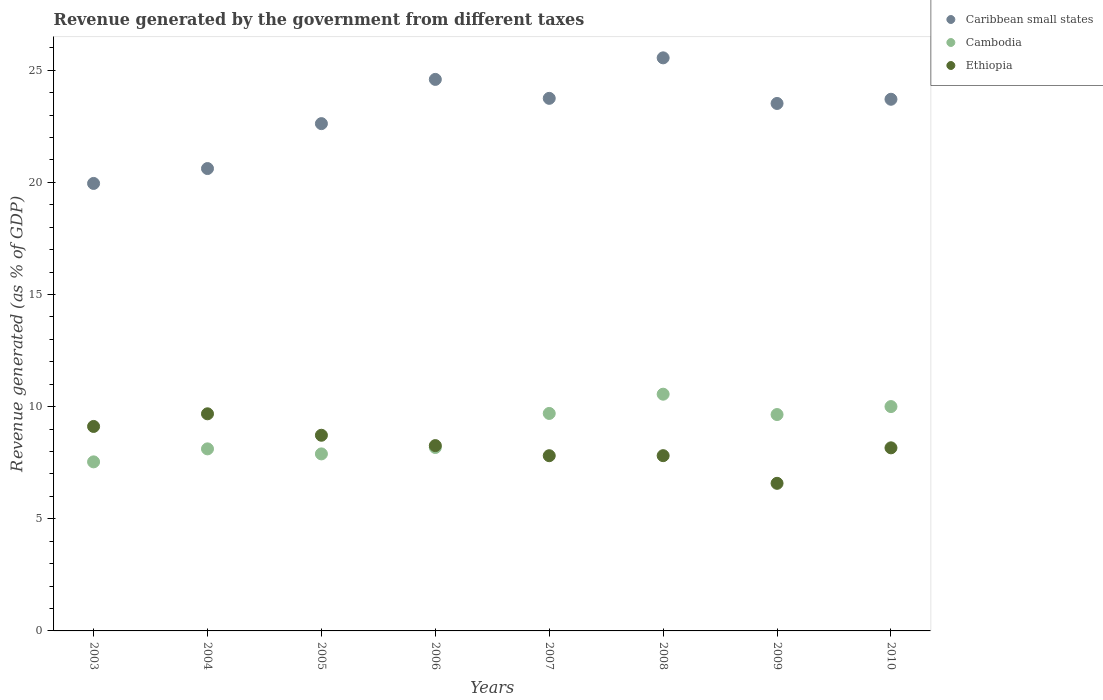How many different coloured dotlines are there?
Ensure brevity in your answer.  3. What is the revenue generated by the government in Ethiopia in 2003?
Make the answer very short. 9.12. Across all years, what is the maximum revenue generated by the government in Cambodia?
Make the answer very short. 10.56. Across all years, what is the minimum revenue generated by the government in Caribbean small states?
Provide a succinct answer. 19.95. In which year was the revenue generated by the government in Ethiopia minimum?
Make the answer very short. 2009. What is the total revenue generated by the government in Ethiopia in the graph?
Your answer should be compact. 66.16. What is the difference between the revenue generated by the government in Ethiopia in 2004 and that in 2006?
Your response must be concise. 1.42. What is the difference between the revenue generated by the government in Ethiopia in 2003 and the revenue generated by the government in Caribbean small states in 2009?
Make the answer very short. -14.4. What is the average revenue generated by the government in Cambodia per year?
Offer a terse response. 8.95. In the year 2008, what is the difference between the revenue generated by the government in Caribbean small states and revenue generated by the government in Ethiopia?
Give a very brief answer. 17.74. In how many years, is the revenue generated by the government in Cambodia greater than 13 %?
Your answer should be very brief. 0. What is the ratio of the revenue generated by the government in Cambodia in 2003 to that in 2008?
Offer a terse response. 0.71. What is the difference between the highest and the second highest revenue generated by the government in Ethiopia?
Give a very brief answer. 0.56. What is the difference between the highest and the lowest revenue generated by the government in Cambodia?
Keep it short and to the point. 3.02. In how many years, is the revenue generated by the government in Caribbean small states greater than the average revenue generated by the government in Caribbean small states taken over all years?
Your response must be concise. 5. Is the revenue generated by the government in Cambodia strictly greater than the revenue generated by the government in Ethiopia over the years?
Make the answer very short. No. What is the difference between two consecutive major ticks on the Y-axis?
Make the answer very short. 5. Does the graph contain any zero values?
Keep it short and to the point. No. Where does the legend appear in the graph?
Give a very brief answer. Top right. How many legend labels are there?
Your answer should be compact. 3. What is the title of the graph?
Keep it short and to the point. Revenue generated by the government from different taxes. What is the label or title of the Y-axis?
Your answer should be compact. Revenue generated (as % of GDP). What is the Revenue generated (as % of GDP) of Caribbean small states in 2003?
Ensure brevity in your answer.  19.95. What is the Revenue generated (as % of GDP) of Cambodia in 2003?
Your response must be concise. 7.54. What is the Revenue generated (as % of GDP) in Ethiopia in 2003?
Your answer should be compact. 9.12. What is the Revenue generated (as % of GDP) in Caribbean small states in 2004?
Your response must be concise. 20.62. What is the Revenue generated (as % of GDP) of Cambodia in 2004?
Make the answer very short. 8.12. What is the Revenue generated (as % of GDP) in Ethiopia in 2004?
Keep it short and to the point. 9.68. What is the Revenue generated (as % of GDP) in Caribbean small states in 2005?
Provide a short and direct response. 22.62. What is the Revenue generated (as % of GDP) in Cambodia in 2005?
Keep it short and to the point. 7.89. What is the Revenue generated (as % of GDP) of Ethiopia in 2005?
Your response must be concise. 8.72. What is the Revenue generated (as % of GDP) of Caribbean small states in 2006?
Your answer should be compact. 24.59. What is the Revenue generated (as % of GDP) of Cambodia in 2006?
Ensure brevity in your answer.  8.18. What is the Revenue generated (as % of GDP) of Ethiopia in 2006?
Offer a very short reply. 8.26. What is the Revenue generated (as % of GDP) in Caribbean small states in 2007?
Provide a succinct answer. 23.75. What is the Revenue generated (as % of GDP) in Cambodia in 2007?
Offer a terse response. 9.7. What is the Revenue generated (as % of GDP) of Ethiopia in 2007?
Provide a succinct answer. 7.81. What is the Revenue generated (as % of GDP) of Caribbean small states in 2008?
Provide a succinct answer. 25.55. What is the Revenue generated (as % of GDP) in Cambodia in 2008?
Keep it short and to the point. 10.56. What is the Revenue generated (as % of GDP) of Ethiopia in 2008?
Provide a short and direct response. 7.81. What is the Revenue generated (as % of GDP) in Caribbean small states in 2009?
Your response must be concise. 23.52. What is the Revenue generated (as % of GDP) of Cambodia in 2009?
Your response must be concise. 9.65. What is the Revenue generated (as % of GDP) in Ethiopia in 2009?
Ensure brevity in your answer.  6.58. What is the Revenue generated (as % of GDP) in Caribbean small states in 2010?
Give a very brief answer. 23.71. What is the Revenue generated (as % of GDP) of Cambodia in 2010?
Provide a succinct answer. 10. What is the Revenue generated (as % of GDP) of Ethiopia in 2010?
Make the answer very short. 8.16. Across all years, what is the maximum Revenue generated (as % of GDP) in Caribbean small states?
Provide a short and direct response. 25.55. Across all years, what is the maximum Revenue generated (as % of GDP) of Cambodia?
Offer a very short reply. 10.56. Across all years, what is the maximum Revenue generated (as % of GDP) of Ethiopia?
Your answer should be compact. 9.68. Across all years, what is the minimum Revenue generated (as % of GDP) in Caribbean small states?
Your answer should be very brief. 19.95. Across all years, what is the minimum Revenue generated (as % of GDP) in Cambodia?
Your answer should be very brief. 7.54. Across all years, what is the minimum Revenue generated (as % of GDP) in Ethiopia?
Provide a succinct answer. 6.58. What is the total Revenue generated (as % of GDP) in Caribbean small states in the graph?
Your answer should be very brief. 184.3. What is the total Revenue generated (as % of GDP) in Cambodia in the graph?
Offer a terse response. 71.63. What is the total Revenue generated (as % of GDP) in Ethiopia in the graph?
Your answer should be compact. 66.16. What is the difference between the Revenue generated (as % of GDP) of Caribbean small states in 2003 and that in 2004?
Make the answer very short. -0.66. What is the difference between the Revenue generated (as % of GDP) of Cambodia in 2003 and that in 2004?
Ensure brevity in your answer.  -0.58. What is the difference between the Revenue generated (as % of GDP) of Ethiopia in 2003 and that in 2004?
Your answer should be compact. -0.56. What is the difference between the Revenue generated (as % of GDP) in Caribbean small states in 2003 and that in 2005?
Make the answer very short. -2.67. What is the difference between the Revenue generated (as % of GDP) of Cambodia in 2003 and that in 2005?
Make the answer very short. -0.36. What is the difference between the Revenue generated (as % of GDP) of Ethiopia in 2003 and that in 2005?
Keep it short and to the point. 0.39. What is the difference between the Revenue generated (as % of GDP) in Caribbean small states in 2003 and that in 2006?
Ensure brevity in your answer.  -4.64. What is the difference between the Revenue generated (as % of GDP) in Cambodia in 2003 and that in 2006?
Ensure brevity in your answer.  -0.64. What is the difference between the Revenue generated (as % of GDP) in Ethiopia in 2003 and that in 2006?
Your answer should be compact. 0.85. What is the difference between the Revenue generated (as % of GDP) of Caribbean small states in 2003 and that in 2007?
Make the answer very short. -3.79. What is the difference between the Revenue generated (as % of GDP) of Cambodia in 2003 and that in 2007?
Provide a short and direct response. -2.16. What is the difference between the Revenue generated (as % of GDP) in Ethiopia in 2003 and that in 2007?
Your answer should be very brief. 1.3. What is the difference between the Revenue generated (as % of GDP) in Caribbean small states in 2003 and that in 2008?
Provide a succinct answer. -5.6. What is the difference between the Revenue generated (as % of GDP) in Cambodia in 2003 and that in 2008?
Your answer should be compact. -3.02. What is the difference between the Revenue generated (as % of GDP) in Ethiopia in 2003 and that in 2008?
Provide a succinct answer. 1.3. What is the difference between the Revenue generated (as % of GDP) of Caribbean small states in 2003 and that in 2009?
Your answer should be very brief. -3.57. What is the difference between the Revenue generated (as % of GDP) in Cambodia in 2003 and that in 2009?
Ensure brevity in your answer.  -2.11. What is the difference between the Revenue generated (as % of GDP) in Ethiopia in 2003 and that in 2009?
Offer a terse response. 2.54. What is the difference between the Revenue generated (as % of GDP) in Caribbean small states in 2003 and that in 2010?
Provide a succinct answer. -3.75. What is the difference between the Revenue generated (as % of GDP) in Cambodia in 2003 and that in 2010?
Ensure brevity in your answer.  -2.47. What is the difference between the Revenue generated (as % of GDP) of Ethiopia in 2003 and that in 2010?
Your response must be concise. 0.95. What is the difference between the Revenue generated (as % of GDP) in Caribbean small states in 2004 and that in 2005?
Provide a short and direct response. -2. What is the difference between the Revenue generated (as % of GDP) in Cambodia in 2004 and that in 2005?
Ensure brevity in your answer.  0.22. What is the difference between the Revenue generated (as % of GDP) of Ethiopia in 2004 and that in 2005?
Your answer should be compact. 0.96. What is the difference between the Revenue generated (as % of GDP) of Caribbean small states in 2004 and that in 2006?
Provide a short and direct response. -3.98. What is the difference between the Revenue generated (as % of GDP) in Cambodia in 2004 and that in 2006?
Your answer should be very brief. -0.06. What is the difference between the Revenue generated (as % of GDP) in Ethiopia in 2004 and that in 2006?
Offer a very short reply. 1.42. What is the difference between the Revenue generated (as % of GDP) in Caribbean small states in 2004 and that in 2007?
Offer a very short reply. -3.13. What is the difference between the Revenue generated (as % of GDP) in Cambodia in 2004 and that in 2007?
Provide a succinct answer. -1.58. What is the difference between the Revenue generated (as % of GDP) in Ethiopia in 2004 and that in 2007?
Provide a succinct answer. 1.87. What is the difference between the Revenue generated (as % of GDP) in Caribbean small states in 2004 and that in 2008?
Provide a succinct answer. -4.94. What is the difference between the Revenue generated (as % of GDP) of Cambodia in 2004 and that in 2008?
Give a very brief answer. -2.44. What is the difference between the Revenue generated (as % of GDP) of Ethiopia in 2004 and that in 2008?
Keep it short and to the point. 1.87. What is the difference between the Revenue generated (as % of GDP) of Caribbean small states in 2004 and that in 2009?
Ensure brevity in your answer.  -2.9. What is the difference between the Revenue generated (as % of GDP) in Cambodia in 2004 and that in 2009?
Provide a short and direct response. -1.53. What is the difference between the Revenue generated (as % of GDP) of Ethiopia in 2004 and that in 2009?
Your answer should be very brief. 3.1. What is the difference between the Revenue generated (as % of GDP) in Caribbean small states in 2004 and that in 2010?
Your answer should be very brief. -3.09. What is the difference between the Revenue generated (as % of GDP) in Cambodia in 2004 and that in 2010?
Offer a terse response. -1.89. What is the difference between the Revenue generated (as % of GDP) in Ethiopia in 2004 and that in 2010?
Keep it short and to the point. 1.52. What is the difference between the Revenue generated (as % of GDP) of Caribbean small states in 2005 and that in 2006?
Keep it short and to the point. -1.97. What is the difference between the Revenue generated (as % of GDP) of Cambodia in 2005 and that in 2006?
Your answer should be very brief. -0.29. What is the difference between the Revenue generated (as % of GDP) in Ethiopia in 2005 and that in 2006?
Your response must be concise. 0.46. What is the difference between the Revenue generated (as % of GDP) of Caribbean small states in 2005 and that in 2007?
Keep it short and to the point. -1.13. What is the difference between the Revenue generated (as % of GDP) of Cambodia in 2005 and that in 2007?
Your response must be concise. -1.8. What is the difference between the Revenue generated (as % of GDP) of Ethiopia in 2005 and that in 2007?
Offer a very short reply. 0.91. What is the difference between the Revenue generated (as % of GDP) in Caribbean small states in 2005 and that in 2008?
Provide a short and direct response. -2.93. What is the difference between the Revenue generated (as % of GDP) in Cambodia in 2005 and that in 2008?
Offer a very short reply. -2.66. What is the difference between the Revenue generated (as % of GDP) of Ethiopia in 2005 and that in 2008?
Provide a short and direct response. 0.91. What is the difference between the Revenue generated (as % of GDP) in Caribbean small states in 2005 and that in 2009?
Provide a short and direct response. -0.9. What is the difference between the Revenue generated (as % of GDP) in Cambodia in 2005 and that in 2009?
Your answer should be compact. -1.75. What is the difference between the Revenue generated (as % of GDP) of Ethiopia in 2005 and that in 2009?
Ensure brevity in your answer.  2.14. What is the difference between the Revenue generated (as % of GDP) of Caribbean small states in 2005 and that in 2010?
Keep it short and to the point. -1.09. What is the difference between the Revenue generated (as % of GDP) of Cambodia in 2005 and that in 2010?
Provide a succinct answer. -2.11. What is the difference between the Revenue generated (as % of GDP) of Ethiopia in 2005 and that in 2010?
Your response must be concise. 0.56. What is the difference between the Revenue generated (as % of GDP) in Caribbean small states in 2006 and that in 2007?
Give a very brief answer. 0.84. What is the difference between the Revenue generated (as % of GDP) in Cambodia in 2006 and that in 2007?
Ensure brevity in your answer.  -1.52. What is the difference between the Revenue generated (as % of GDP) of Ethiopia in 2006 and that in 2007?
Ensure brevity in your answer.  0.45. What is the difference between the Revenue generated (as % of GDP) of Caribbean small states in 2006 and that in 2008?
Keep it short and to the point. -0.96. What is the difference between the Revenue generated (as % of GDP) in Cambodia in 2006 and that in 2008?
Your answer should be compact. -2.38. What is the difference between the Revenue generated (as % of GDP) in Ethiopia in 2006 and that in 2008?
Your response must be concise. 0.45. What is the difference between the Revenue generated (as % of GDP) in Caribbean small states in 2006 and that in 2009?
Offer a very short reply. 1.07. What is the difference between the Revenue generated (as % of GDP) in Cambodia in 2006 and that in 2009?
Give a very brief answer. -1.47. What is the difference between the Revenue generated (as % of GDP) in Ethiopia in 2006 and that in 2009?
Provide a succinct answer. 1.68. What is the difference between the Revenue generated (as % of GDP) of Caribbean small states in 2006 and that in 2010?
Provide a short and direct response. 0.89. What is the difference between the Revenue generated (as % of GDP) in Cambodia in 2006 and that in 2010?
Your response must be concise. -1.82. What is the difference between the Revenue generated (as % of GDP) in Ethiopia in 2006 and that in 2010?
Offer a terse response. 0.1. What is the difference between the Revenue generated (as % of GDP) of Caribbean small states in 2007 and that in 2008?
Your response must be concise. -1.81. What is the difference between the Revenue generated (as % of GDP) in Cambodia in 2007 and that in 2008?
Offer a very short reply. -0.86. What is the difference between the Revenue generated (as % of GDP) in Ethiopia in 2007 and that in 2008?
Give a very brief answer. -0. What is the difference between the Revenue generated (as % of GDP) in Caribbean small states in 2007 and that in 2009?
Offer a terse response. 0.23. What is the difference between the Revenue generated (as % of GDP) in Cambodia in 2007 and that in 2009?
Your response must be concise. 0.05. What is the difference between the Revenue generated (as % of GDP) of Ethiopia in 2007 and that in 2009?
Provide a succinct answer. 1.23. What is the difference between the Revenue generated (as % of GDP) of Caribbean small states in 2007 and that in 2010?
Keep it short and to the point. 0.04. What is the difference between the Revenue generated (as % of GDP) in Cambodia in 2007 and that in 2010?
Offer a terse response. -0.31. What is the difference between the Revenue generated (as % of GDP) in Ethiopia in 2007 and that in 2010?
Provide a succinct answer. -0.35. What is the difference between the Revenue generated (as % of GDP) in Caribbean small states in 2008 and that in 2009?
Provide a short and direct response. 2.03. What is the difference between the Revenue generated (as % of GDP) in Cambodia in 2008 and that in 2009?
Make the answer very short. 0.91. What is the difference between the Revenue generated (as % of GDP) in Ethiopia in 2008 and that in 2009?
Provide a short and direct response. 1.23. What is the difference between the Revenue generated (as % of GDP) in Caribbean small states in 2008 and that in 2010?
Provide a short and direct response. 1.85. What is the difference between the Revenue generated (as % of GDP) in Cambodia in 2008 and that in 2010?
Give a very brief answer. 0.55. What is the difference between the Revenue generated (as % of GDP) in Ethiopia in 2008 and that in 2010?
Provide a succinct answer. -0.35. What is the difference between the Revenue generated (as % of GDP) in Caribbean small states in 2009 and that in 2010?
Provide a succinct answer. -0.19. What is the difference between the Revenue generated (as % of GDP) in Cambodia in 2009 and that in 2010?
Offer a very short reply. -0.36. What is the difference between the Revenue generated (as % of GDP) of Ethiopia in 2009 and that in 2010?
Ensure brevity in your answer.  -1.58. What is the difference between the Revenue generated (as % of GDP) of Caribbean small states in 2003 and the Revenue generated (as % of GDP) of Cambodia in 2004?
Your answer should be compact. 11.84. What is the difference between the Revenue generated (as % of GDP) in Caribbean small states in 2003 and the Revenue generated (as % of GDP) in Ethiopia in 2004?
Your response must be concise. 10.27. What is the difference between the Revenue generated (as % of GDP) in Cambodia in 2003 and the Revenue generated (as % of GDP) in Ethiopia in 2004?
Your answer should be very brief. -2.14. What is the difference between the Revenue generated (as % of GDP) of Caribbean small states in 2003 and the Revenue generated (as % of GDP) of Cambodia in 2005?
Make the answer very short. 12.06. What is the difference between the Revenue generated (as % of GDP) in Caribbean small states in 2003 and the Revenue generated (as % of GDP) in Ethiopia in 2005?
Your response must be concise. 11.23. What is the difference between the Revenue generated (as % of GDP) of Cambodia in 2003 and the Revenue generated (as % of GDP) of Ethiopia in 2005?
Provide a succinct answer. -1.19. What is the difference between the Revenue generated (as % of GDP) in Caribbean small states in 2003 and the Revenue generated (as % of GDP) in Cambodia in 2006?
Offer a terse response. 11.77. What is the difference between the Revenue generated (as % of GDP) of Caribbean small states in 2003 and the Revenue generated (as % of GDP) of Ethiopia in 2006?
Keep it short and to the point. 11.69. What is the difference between the Revenue generated (as % of GDP) in Cambodia in 2003 and the Revenue generated (as % of GDP) in Ethiopia in 2006?
Offer a terse response. -0.72. What is the difference between the Revenue generated (as % of GDP) of Caribbean small states in 2003 and the Revenue generated (as % of GDP) of Cambodia in 2007?
Offer a terse response. 10.26. What is the difference between the Revenue generated (as % of GDP) in Caribbean small states in 2003 and the Revenue generated (as % of GDP) in Ethiopia in 2007?
Offer a very short reply. 12.14. What is the difference between the Revenue generated (as % of GDP) of Cambodia in 2003 and the Revenue generated (as % of GDP) of Ethiopia in 2007?
Your response must be concise. -0.27. What is the difference between the Revenue generated (as % of GDP) of Caribbean small states in 2003 and the Revenue generated (as % of GDP) of Cambodia in 2008?
Your answer should be compact. 9.4. What is the difference between the Revenue generated (as % of GDP) in Caribbean small states in 2003 and the Revenue generated (as % of GDP) in Ethiopia in 2008?
Your answer should be compact. 12.14. What is the difference between the Revenue generated (as % of GDP) of Cambodia in 2003 and the Revenue generated (as % of GDP) of Ethiopia in 2008?
Ensure brevity in your answer.  -0.28. What is the difference between the Revenue generated (as % of GDP) in Caribbean small states in 2003 and the Revenue generated (as % of GDP) in Cambodia in 2009?
Provide a short and direct response. 10.3. What is the difference between the Revenue generated (as % of GDP) in Caribbean small states in 2003 and the Revenue generated (as % of GDP) in Ethiopia in 2009?
Provide a succinct answer. 13.37. What is the difference between the Revenue generated (as % of GDP) in Cambodia in 2003 and the Revenue generated (as % of GDP) in Ethiopia in 2009?
Offer a terse response. 0.96. What is the difference between the Revenue generated (as % of GDP) in Caribbean small states in 2003 and the Revenue generated (as % of GDP) in Cambodia in 2010?
Make the answer very short. 9.95. What is the difference between the Revenue generated (as % of GDP) of Caribbean small states in 2003 and the Revenue generated (as % of GDP) of Ethiopia in 2010?
Ensure brevity in your answer.  11.79. What is the difference between the Revenue generated (as % of GDP) of Cambodia in 2003 and the Revenue generated (as % of GDP) of Ethiopia in 2010?
Make the answer very short. -0.63. What is the difference between the Revenue generated (as % of GDP) in Caribbean small states in 2004 and the Revenue generated (as % of GDP) in Cambodia in 2005?
Offer a very short reply. 12.72. What is the difference between the Revenue generated (as % of GDP) in Caribbean small states in 2004 and the Revenue generated (as % of GDP) in Ethiopia in 2005?
Provide a short and direct response. 11.89. What is the difference between the Revenue generated (as % of GDP) of Cambodia in 2004 and the Revenue generated (as % of GDP) of Ethiopia in 2005?
Provide a succinct answer. -0.61. What is the difference between the Revenue generated (as % of GDP) in Caribbean small states in 2004 and the Revenue generated (as % of GDP) in Cambodia in 2006?
Offer a terse response. 12.44. What is the difference between the Revenue generated (as % of GDP) of Caribbean small states in 2004 and the Revenue generated (as % of GDP) of Ethiopia in 2006?
Provide a succinct answer. 12.35. What is the difference between the Revenue generated (as % of GDP) in Cambodia in 2004 and the Revenue generated (as % of GDP) in Ethiopia in 2006?
Make the answer very short. -0.15. What is the difference between the Revenue generated (as % of GDP) of Caribbean small states in 2004 and the Revenue generated (as % of GDP) of Cambodia in 2007?
Your answer should be compact. 10.92. What is the difference between the Revenue generated (as % of GDP) of Caribbean small states in 2004 and the Revenue generated (as % of GDP) of Ethiopia in 2007?
Your answer should be compact. 12.8. What is the difference between the Revenue generated (as % of GDP) of Cambodia in 2004 and the Revenue generated (as % of GDP) of Ethiopia in 2007?
Offer a terse response. 0.3. What is the difference between the Revenue generated (as % of GDP) of Caribbean small states in 2004 and the Revenue generated (as % of GDP) of Cambodia in 2008?
Your answer should be very brief. 10.06. What is the difference between the Revenue generated (as % of GDP) of Caribbean small states in 2004 and the Revenue generated (as % of GDP) of Ethiopia in 2008?
Your answer should be compact. 12.8. What is the difference between the Revenue generated (as % of GDP) of Cambodia in 2004 and the Revenue generated (as % of GDP) of Ethiopia in 2008?
Your answer should be very brief. 0.3. What is the difference between the Revenue generated (as % of GDP) of Caribbean small states in 2004 and the Revenue generated (as % of GDP) of Cambodia in 2009?
Offer a terse response. 10.97. What is the difference between the Revenue generated (as % of GDP) in Caribbean small states in 2004 and the Revenue generated (as % of GDP) in Ethiopia in 2009?
Provide a short and direct response. 14.04. What is the difference between the Revenue generated (as % of GDP) of Cambodia in 2004 and the Revenue generated (as % of GDP) of Ethiopia in 2009?
Offer a very short reply. 1.54. What is the difference between the Revenue generated (as % of GDP) of Caribbean small states in 2004 and the Revenue generated (as % of GDP) of Cambodia in 2010?
Provide a short and direct response. 10.61. What is the difference between the Revenue generated (as % of GDP) of Caribbean small states in 2004 and the Revenue generated (as % of GDP) of Ethiopia in 2010?
Give a very brief answer. 12.45. What is the difference between the Revenue generated (as % of GDP) of Cambodia in 2004 and the Revenue generated (as % of GDP) of Ethiopia in 2010?
Offer a very short reply. -0.05. What is the difference between the Revenue generated (as % of GDP) in Caribbean small states in 2005 and the Revenue generated (as % of GDP) in Cambodia in 2006?
Make the answer very short. 14.44. What is the difference between the Revenue generated (as % of GDP) of Caribbean small states in 2005 and the Revenue generated (as % of GDP) of Ethiopia in 2006?
Your answer should be compact. 14.36. What is the difference between the Revenue generated (as % of GDP) of Cambodia in 2005 and the Revenue generated (as % of GDP) of Ethiopia in 2006?
Your response must be concise. -0.37. What is the difference between the Revenue generated (as % of GDP) in Caribbean small states in 2005 and the Revenue generated (as % of GDP) in Cambodia in 2007?
Provide a succinct answer. 12.92. What is the difference between the Revenue generated (as % of GDP) of Caribbean small states in 2005 and the Revenue generated (as % of GDP) of Ethiopia in 2007?
Your answer should be compact. 14.81. What is the difference between the Revenue generated (as % of GDP) in Cambodia in 2005 and the Revenue generated (as % of GDP) in Ethiopia in 2007?
Offer a terse response. 0.08. What is the difference between the Revenue generated (as % of GDP) in Caribbean small states in 2005 and the Revenue generated (as % of GDP) in Cambodia in 2008?
Offer a very short reply. 12.06. What is the difference between the Revenue generated (as % of GDP) in Caribbean small states in 2005 and the Revenue generated (as % of GDP) in Ethiopia in 2008?
Your response must be concise. 14.8. What is the difference between the Revenue generated (as % of GDP) in Cambodia in 2005 and the Revenue generated (as % of GDP) in Ethiopia in 2008?
Offer a terse response. 0.08. What is the difference between the Revenue generated (as % of GDP) in Caribbean small states in 2005 and the Revenue generated (as % of GDP) in Cambodia in 2009?
Give a very brief answer. 12.97. What is the difference between the Revenue generated (as % of GDP) of Caribbean small states in 2005 and the Revenue generated (as % of GDP) of Ethiopia in 2009?
Your answer should be very brief. 16.04. What is the difference between the Revenue generated (as % of GDP) in Cambodia in 2005 and the Revenue generated (as % of GDP) in Ethiopia in 2009?
Provide a short and direct response. 1.31. What is the difference between the Revenue generated (as % of GDP) of Caribbean small states in 2005 and the Revenue generated (as % of GDP) of Cambodia in 2010?
Provide a short and direct response. 12.62. What is the difference between the Revenue generated (as % of GDP) of Caribbean small states in 2005 and the Revenue generated (as % of GDP) of Ethiopia in 2010?
Your answer should be compact. 14.46. What is the difference between the Revenue generated (as % of GDP) of Cambodia in 2005 and the Revenue generated (as % of GDP) of Ethiopia in 2010?
Ensure brevity in your answer.  -0.27. What is the difference between the Revenue generated (as % of GDP) in Caribbean small states in 2006 and the Revenue generated (as % of GDP) in Cambodia in 2007?
Your answer should be compact. 14.89. What is the difference between the Revenue generated (as % of GDP) of Caribbean small states in 2006 and the Revenue generated (as % of GDP) of Ethiopia in 2007?
Offer a very short reply. 16.78. What is the difference between the Revenue generated (as % of GDP) of Cambodia in 2006 and the Revenue generated (as % of GDP) of Ethiopia in 2007?
Give a very brief answer. 0.37. What is the difference between the Revenue generated (as % of GDP) of Caribbean small states in 2006 and the Revenue generated (as % of GDP) of Cambodia in 2008?
Ensure brevity in your answer.  14.04. What is the difference between the Revenue generated (as % of GDP) of Caribbean small states in 2006 and the Revenue generated (as % of GDP) of Ethiopia in 2008?
Offer a very short reply. 16.78. What is the difference between the Revenue generated (as % of GDP) in Cambodia in 2006 and the Revenue generated (as % of GDP) in Ethiopia in 2008?
Keep it short and to the point. 0.36. What is the difference between the Revenue generated (as % of GDP) of Caribbean small states in 2006 and the Revenue generated (as % of GDP) of Cambodia in 2009?
Offer a terse response. 14.94. What is the difference between the Revenue generated (as % of GDP) of Caribbean small states in 2006 and the Revenue generated (as % of GDP) of Ethiopia in 2009?
Offer a terse response. 18.01. What is the difference between the Revenue generated (as % of GDP) of Cambodia in 2006 and the Revenue generated (as % of GDP) of Ethiopia in 2009?
Keep it short and to the point. 1.6. What is the difference between the Revenue generated (as % of GDP) in Caribbean small states in 2006 and the Revenue generated (as % of GDP) in Cambodia in 2010?
Ensure brevity in your answer.  14.59. What is the difference between the Revenue generated (as % of GDP) of Caribbean small states in 2006 and the Revenue generated (as % of GDP) of Ethiopia in 2010?
Your answer should be very brief. 16.43. What is the difference between the Revenue generated (as % of GDP) in Cambodia in 2006 and the Revenue generated (as % of GDP) in Ethiopia in 2010?
Provide a succinct answer. 0.02. What is the difference between the Revenue generated (as % of GDP) in Caribbean small states in 2007 and the Revenue generated (as % of GDP) in Cambodia in 2008?
Your answer should be very brief. 13.19. What is the difference between the Revenue generated (as % of GDP) of Caribbean small states in 2007 and the Revenue generated (as % of GDP) of Ethiopia in 2008?
Provide a short and direct response. 15.93. What is the difference between the Revenue generated (as % of GDP) in Cambodia in 2007 and the Revenue generated (as % of GDP) in Ethiopia in 2008?
Keep it short and to the point. 1.88. What is the difference between the Revenue generated (as % of GDP) in Caribbean small states in 2007 and the Revenue generated (as % of GDP) in Cambodia in 2009?
Ensure brevity in your answer.  14.1. What is the difference between the Revenue generated (as % of GDP) in Caribbean small states in 2007 and the Revenue generated (as % of GDP) in Ethiopia in 2009?
Make the answer very short. 17.17. What is the difference between the Revenue generated (as % of GDP) in Cambodia in 2007 and the Revenue generated (as % of GDP) in Ethiopia in 2009?
Provide a succinct answer. 3.12. What is the difference between the Revenue generated (as % of GDP) of Caribbean small states in 2007 and the Revenue generated (as % of GDP) of Cambodia in 2010?
Your answer should be very brief. 13.74. What is the difference between the Revenue generated (as % of GDP) of Caribbean small states in 2007 and the Revenue generated (as % of GDP) of Ethiopia in 2010?
Provide a short and direct response. 15.58. What is the difference between the Revenue generated (as % of GDP) of Cambodia in 2007 and the Revenue generated (as % of GDP) of Ethiopia in 2010?
Give a very brief answer. 1.53. What is the difference between the Revenue generated (as % of GDP) of Caribbean small states in 2008 and the Revenue generated (as % of GDP) of Cambodia in 2009?
Make the answer very short. 15.9. What is the difference between the Revenue generated (as % of GDP) of Caribbean small states in 2008 and the Revenue generated (as % of GDP) of Ethiopia in 2009?
Your response must be concise. 18.97. What is the difference between the Revenue generated (as % of GDP) of Cambodia in 2008 and the Revenue generated (as % of GDP) of Ethiopia in 2009?
Offer a very short reply. 3.97. What is the difference between the Revenue generated (as % of GDP) of Caribbean small states in 2008 and the Revenue generated (as % of GDP) of Cambodia in 2010?
Ensure brevity in your answer.  15.55. What is the difference between the Revenue generated (as % of GDP) of Caribbean small states in 2008 and the Revenue generated (as % of GDP) of Ethiopia in 2010?
Offer a very short reply. 17.39. What is the difference between the Revenue generated (as % of GDP) in Cambodia in 2008 and the Revenue generated (as % of GDP) in Ethiopia in 2010?
Offer a very short reply. 2.39. What is the difference between the Revenue generated (as % of GDP) in Caribbean small states in 2009 and the Revenue generated (as % of GDP) in Cambodia in 2010?
Make the answer very short. 13.52. What is the difference between the Revenue generated (as % of GDP) of Caribbean small states in 2009 and the Revenue generated (as % of GDP) of Ethiopia in 2010?
Offer a very short reply. 15.36. What is the difference between the Revenue generated (as % of GDP) in Cambodia in 2009 and the Revenue generated (as % of GDP) in Ethiopia in 2010?
Your answer should be very brief. 1.48. What is the average Revenue generated (as % of GDP) in Caribbean small states per year?
Your response must be concise. 23.04. What is the average Revenue generated (as % of GDP) in Cambodia per year?
Your response must be concise. 8.95. What is the average Revenue generated (as % of GDP) in Ethiopia per year?
Your answer should be very brief. 8.27. In the year 2003, what is the difference between the Revenue generated (as % of GDP) in Caribbean small states and Revenue generated (as % of GDP) in Cambodia?
Your response must be concise. 12.41. In the year 2003, what is the difference between the Revenue generated (as % of GDP) in Caribbean small states and Revenue generated (as % of GDP) in Ethiopia?
Your answer should be compact. 10.84. In the year 2003, what is the difference between the Revenue generated (as % of GDP) of Cambodia and Revenue generated (as % of GDP) of Ethiopia?
Give a very brief answer. -1.58. In the year 2004, what is the difference between the Revenue generated (as % of GDP) of Caribbean small states and Revenue generated (as % of GDP) of Cambodia?
Ensure brevity in your answer.  12.5. In the year 2004, what is the difference between the Revenue generated (as % of GDP) of Caribbean small states and Revenue generated (as % of GDP) of Ethiopia?
Ensure brevity in your answer.  10.94. In the year 2004, what is the difference between the Revenue generated (as % of GDP) of Cambodia and Revenue generated (as % of GDP) of Ethiopia?
Make the answer very short. -1.56. In the year 2005, what is the difference between the Revenue generated (as % of GDP) in Caribbean small states and Revenue generated (as % of GDP) in Cambodia?
Your answer should be very brief. 14.73. In the year 2005, what is the difference between the Revenue generated (as % of GDP) of Caribbean small states and Revenue generated (as % of GDP) of Ethiopia?
Your answer should be very brief. 13.89. In the year 2005, what is the difference between the Revenue generated (as % of GDP) of Cambodia and Revenue generated (as % of GDP) of Ethiopia?
Offer a terse response. -0.83. In the year 2006, what is the difference between the Revenue generated (as % of GDP) in Caribbean small states and Revenue generated (as % of GDP) in Cambodia?
Your response must be concise. 16.41. In the year 2006, what is the difference between the Revenue generated (as % of GDP) in Caribbean small states and Revenue generated (as % of GDP) in Ethiopia?
Offer a terse response. 16.33. In the year 2006, what is the difference between the Revenue generated (as % of GDP) in Cambodia and Revenue generated (as % of GDP) in Ethiopia?
Give a very brief answer. -0.08. In the year 2007, what is the difference between the Revenue generated (as % of GDP) of Caribbean small states and Revenue generated (as % of GDP) of Cambodia?
Make the answer very short. 14.05. In the year 2007, what is the difference between the Revenue generated (as % of GDP) in Caribbean small states and Revenue generated (as % of GDP) in Ethiopia?
Offer a terse response. 15.93. In the year 2007, what is the difference between the Revenue generated (as % of GDP) of Cambodia and Revenue generated (as % of GDP) of Ethiopia?
Offer a terse response. 1.88. In the year 2008, what is the difference between the Revenue generated (as % of GDP) in Caribbean small states and Revenue generated (as % of GDP) in Cambodia?
Provide a succinct answer. 15. In the year 2008, what is the difference between the Revenue generated (as % of GDP) in Caribbean small states and Revenue generated (as % of GDP) in Ethiopia?
Keep it short and to the point. 17.74. In the year 2008, what is the difference between the Revenue generated (as % of GDP) in Cambodia and Revenue generated (as % of GDP) in Ethiopia?
Offer a very short reply. 2.74. In the year 2009, what is the difference between the Revenue generated (as % of GDP) of Caribbean small states and Revenue generated (as % of GDP) of Cambodia?
Keep it short and to the point. 13.87. In the year 2009, what is the difference between the Revenue generated (as % of GDP) of Caribbean small states and Revenue generated (as % of GDP) of Ethiopia?
Your response must be concise. 16.94. In the year 2009, what is the difference between the Revenue generated (as % of GDP) of Cambodia and Revenue generated (as % of GDP) of Ethiopia?
Provide a succinct answer. 3.07. In the year 2010, what is the difference between the Revenue generated (as % of GDP) of Caribbean small states and Revenue generated (as % of GDP) of Cambodia?
Your answer should be compact. 13.7. In the year 2010, what is the difference between the Revenue generated (as % of GDP) of Caribbean small states and Revenue generated (as % of GDP) of Ethiopia?
Your response must be concise. 15.54. In the year 2010, what is the difference between the Revenue generated (as % of GDP) in Cambodia and Revenue generated (as % of GDP) in Ethiopia?
Make the answer very short. 1.84. What is the ratio of the Revenue generated (as % of GDP) in Caribbean small states in 2003 to that in 2004?
Offer a terse response. 0.97. What is the ratio of the Revenue generated (as % of GDP) in Cambodia in 2003 to that in 2004?
Ensure brevity in your answer.  0.93. What is the ratio of the Revenue generated (as % of GDP) of Ethiopia in 2003 to that in 2004?
Offer a terse response. 0.94. What is the ratio of the Revenue generated (as % of GDP) of Caribbean small states in 2003 to that in 2005?
Your answer should be very brief. 0.88. What is the ratio of the Revenue generated (as % of GDP) of Cambodia in 2003 to that in 2005?
Keep it short and to the point. 0.95. What is the ratio of the Revenue generated (as % of GDP) in Ethiopia in 2003 to that in 2005?
Keep it short and to the point. 1.04. What is the ratio of the Revenue generated (as % of GDP) of Caribbean small states in 2003 to that in 2006?
Make the answer very short. 0.81. What is the ratio of the Revenue generated (as % of GDP) of Cambodia in 2003 to that in 2006?
Provide a succinct answer. 0.92. What is the ratio of the Revenue generated (as % of GDP) in Ethiopia in 2003 to that in 2006?
Make the answer very short. 1.1. What is the ratio of the Revenue generated (as % of GDP) in Caribbean small states in 2003 to that in 2007?
Offer a terse response. 0.84. What is the ratio of the Revenue generated (as % of GDP) in Cambodia in 2003 to that in 2007?
Your answer should be very brief. 0.78. What is the ratio of the Revenue generated (as % of GDP) in Ethiopia in 2003 to that in 2007?
Offer a terse response. 1.17. What is the ratio of the Revenue generated (as % of GDP) in Caribbean small states in 2003 to that in 2008?
Make the answer very short. 0.78. What is the ratio of the Revenue generated (as % of GDP) in Cambodia in 2003 to that in 2008?
Your answer should be very brief. 0.71. What is the ratio of the Revenue generated (as % of GDP) of Caribbean small states in 2003 to that in 2009?
Provide a succinct answer. 0.85. What is the ratio of the Revenue generated (as % of GDP) in Cambodia in 2003 to that in 2009?
Give a very brief answer. 0.78. What is the ratio of the Revenue generated (as % of GDP) of Ethiopia in 2003 to that in 2009?
Make the answer very short. 1.39. What is the ratio of the Revenue generated (as % of GDP) in Caribbean small states in 2003 to that in 2010?
Your answer should be very brief. 0.84. What is the ratio of the Revenue generated (as % of GDP) in Cambodia in 2003 to that in 2010?
Keep it short and to the point. 0.75. What is the ratio of the Revenue generated (as % of GDP) in Ethiopia in 2003 to that in 2010?
Keep it short and to the point. 1.12. What is the ratio of the Revenue generated (as % of GDP) of Caribbean small states in 2004 to that in 2005?
Provide a short and direct response. 0.91. What is the ratio of the Revenue generated (as % of GDP) in Cambodia in 2004 to that in 2005?
Give a very brief answer. 1.03. What is the ratio of the Revenue generated (as % of GDP) of Ethiopia in 2004 to that in 2005?
Ensure brevity in your answer.  1.11. What is the ratio of the Revenue generated (as % of GDP) of Caribbean small states in 2004 to that in 2006?
Give a very brief answer. 0.84. What is the ratio of the Revenue generated (as % of GDP) in Ethiopia in 2004 to that in 2006?
Make the answer very short. 1.17. What is the ratio of the Revenue generated (as % of GDP) in Caribbean small states in 2004 to that in 2007?
Provide a succinct answer. 0.87. What is the ratio of the Revenue generated (as % of GDP) of Cambodia in 2004 to that in 2007?
Offer a very short reply. 0.84. What is the ratio of the Revenue generated (as % of GDP) of Ethiopia in 2004 to that in 2007?
Provide a short and direct response. 1.24. What is the ratio of the Revenue generated (as % of GDP) in Caribbean small states in 2004 to that in 2008?
Provide a short and direct response. 0.81. What is the ratio of the Revenue generated (as % of GDP) of Cambodia in 2004 to that in 2008?
Offer a very short reply. 0.77. What is the ratio of the Revenue generated (as % of GDP) of Ethiopia in 2004 to that in 2008?
Give a very brief answer. 1.24. What is the ratio of the Revenue generated (as % of GDP) in Caribbean small states in 2004 to that in 2009?
Offer a terse response. 0.88. What is the ratio of the Revenue generated (as % of GDP) of Cambodia in 2004 to that in 2009?
Give a very brief answer. 0.84. What is the ratio of the Revenue generated (as % of GDP) of Ethiopia in 2004 to that in 2009?
Provide a short and direct response. 1.47. What is the ratio of the Revenue generated (as % of GDP) of Caribbean small states in 2004 to that in 2010?
Offer a very short reply. 0.87. What is the ratio of the Revenue generated (as % of GDP) in Cambodia in 2004 to that in 2010?
Offer a terse response. 0.81. What is the ratio of the Revenue generated (as % of GDP) in Ethiopia in 2004 to that in 2010?
Your response must be concise. 1.19. What is the ratio of the Revenue generated (as % of GDP) of Caribbean small states in 2005 to that in 2006?
Keep it short and to the point. 0.92. What is the ratio of the Revenue generated (as % of GDP) of Cambodia in 2005 to that in 2006?
Ensure brevity in your answer.  0.97. What is the ratio of the Revenue generated (as % of GDP) in Ethiopia in 2005 to that in 2006?
Provide a succinct answer. 1.06. What is the ratio of the Revenue generated (as % of GDP) of Caribbean small states in 2005 to that in 2007?
Your answer should be very brief. 0.95. What is the ratio of the Revenue generated (as % of GDP) in Cambodia in 2005 to that in 2007?
Offer a terse response. 0.81. What is the ratio of the Revenue generated (as % of GDP) in Ethiopia in 2005 to that in 2007?
Your response must be concise. 1.12. What is the ratio of the Revenue generated (as % of GDP) of Caribbean small states in 2005 to that in 2008?
Your response must be concise. 0.89. What is the ratio of the Revenue generated (as % of GDP) of Cambodia in 2005 to that in 2008?
Offer a very short reply. 0.75. What is the ratio of the Revenue generated (as % of GDP) of Ethiopia in 2005 to that in 2008?
Provide a succinct answer. 1.12. What is the ratio of the Revenue generated (as % of GDP) of Caribbean small states in 2005 to that in 2009?
Make the answer very short. 0.96. What is the ratio of the Revenue generated (as % of GDP) of Cambodia in 2005 to that in 2009?
Ensure brevity in your answer.  0.82. What is the ratio of the Revenue generated (as % of GDP) in Ethiopia in 2005 to that in 2009?
Offer a very short reply. 1.33. What is the ratio of the Revenue generated (as % of GDP) of Caribbean small states in 2005 to that in 2010?
Your answer should be very brief. 0.95. What is the ratio of the Revenue generated (as % of GDP) of Cambodia in 2005 to that in 2010?
Ensure brevity in your answer.  0.79. What is the ratio of the Revenue generated (as % of GDP) of Ethiopia in 2005 to that in 2010?
Your answer should be very brief. 1.07. What is the ratio of the Revenue generated (as % of GDP) in Caribbean small states in 2006 to that in 2007?
Offer a terse response. 1.04. What is the ratio of the Revenue generated (as % of GDP) of Cambodia in 2006 to that in 2007?
Provide a succinct answer. 0.84. What is the ratio of the Revenue generated (as % of GDP) in Ethiopia in 2006 to that in 2007?
Offer a terse response. 1.06. What is the ratio of the Revenue generated (as % of GDP) of Caribbean small states in 2006 to that in 2008?
Make the answer very short. 0.96. What is the ratio of the Revenue generated (as % of GDP) in Cambodia in 2006 to that in 2008?
Provide a succinct answer. 0.77. What is the ratio of the Revenue generated (as % of GDP) of Ethiopia in 2006 to that in 2008?
Give a very brief answer. 1.06. What is the ratio of the Revenue generated (as % of GDP) of Caribbean small states in 2006 to that in 2009?
Give a very brief answer. 1.05. What is the ratio of the Revenue generated (as % of GDP) of Cambodia in 2006 to that in 2009?
Your response must be concise. 0.85. What is the ratio of the Revenue generated (as % of GDP) in Ethiopia in 2006 to that in 2009?
Your response must be concise. 1.26. What is the ratio of the Revenue generated (as % of GDP) in Caribbean small states in 2006 to that in 2010?
Provide a succinct answer. 1.04. What is the ratio of the Revenue generated (as % of GDP) in Cambodia in 2006 to that in 2010?
Ensure brevity in your answer.  0.82. What is the ratio of the Revenue generated (as % of GDP) in Ethiopia in 2006 to that in 2010?
Provide a succinct answer. 1.01. What is the ratio of the Revenue generated (as % of GDP) in Caribbean small states in 2007 to that in 2008?
Give a very brief answer. 0.93. What is the ratio of the Revenue generated (as % of GDP) of Cambodia in 2007 to that in 2008?
Offer a very short reply. 0.92. What is the ratio of the Revenue generated (as % of GDP) of Ethiopia in 2007 to that in 2008?
Provide a succinct answer. 1. What is the ratio of the Revenue generated (as % of GDP) of Caribbean small states in 2007 to that in 2009?
Make the answer very short. 1.01. What is the ratio of the Revenue generated (as % of GDP) of Ethiopia in 2007 to that in 2009?
Keep it short and to the point. 1.19. What is the ratio of the Revenue generated (as % of GDP) in Caribbean small states in 2007 to that in 2010?
Give a very brief answer. 1. What is the ratio of the Revenue generated (as % of GDP) of Cambodia in 2007 to that in 2010?
Offer a terse response. 0.97. What is the ratio of the Revenue generated (as % of GDP) of Caribbean small states in 2008 to that in 2009?
Make the answer very short. 1.09. What is the ratio of the Revenue generated (as % of GDP) in Cambodia in 2008 to that in 2009?
Keep it short and to the point. 1.09. What is the ratio of the Revenue generated (as % of GDP) of Ethiopia in 2008 to that in 2009?
Give a very brief answer. 1.19. What is the ratio of the Revenue generated (as % of GDP) of Caribbean small states in 2008 to that in 2010?
Provide a short and direct response. 1.08. What is the ratio of the Revenue generated (as % of GDP) of Cambodia in 2008 to that in 2010?
Keep it short and to the point. 1.06. What is the ratio of the Revenue generated (as % of GDP) of Ethiopia in 2008 to that in 2010?
Provide a succinct answer. 0.96. What is the ratio of the Revenue generated (as % of GDP) of Caribbean small states in 2009 to that in 2010?
Make the answer very short. 0.99. What is the ratio of the Revenue generated (as % of GDP) in Cambodia in 2009 to that in 2010?
Your answer should be compact. 0.96. What is the ratio of the Revenue generated (as % of GDP) of Ethiopia in 2009 to that in 2010?
Give a very brief answer. 0.81. What is the difference between the highest and the second highest Revenue generated (as % of GDP) in Caribbean small states?
Ensure brevity in your answer.  0.96. What is the difference between the highest and the second highest Revenue generated (as % of GDP) in Cambodia?
Offer a terse response. 0.55. What is the difference between the highest and the second highest Revenue generated (as % of GDP) in Ethiopia?
Your answer should be compact. 0.56. What is the difference between the highest and the lowest Revenue generated (as % of GDP) of Caribbean small states?
Ensure brevity in your answer.  5.6. What is the difference between the highest and the lowest Revenue generated (as % of GDP) of Cambodia?
Give a very brief answer. 3.02. What is the difference between the highest and the lowest Revenue generated (as % of GDP) in Ethiopia?
Make the answer very short. 3.1. 